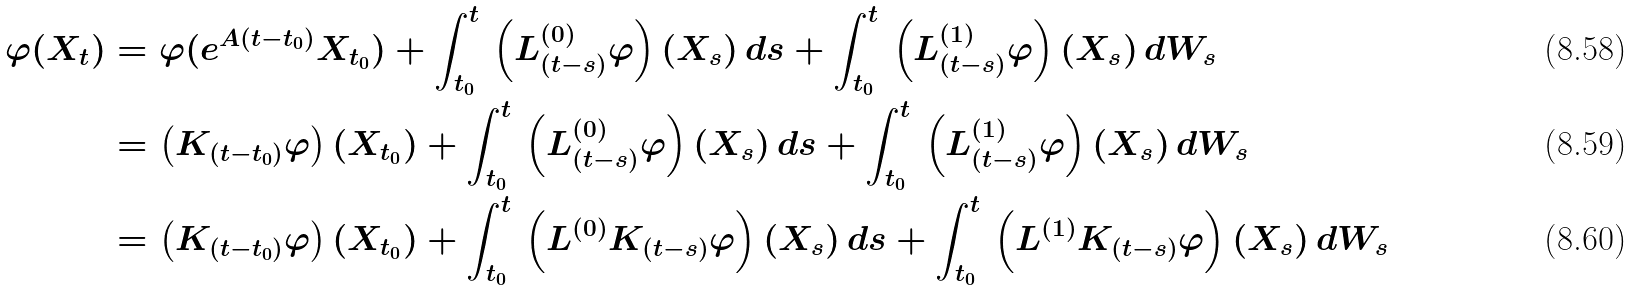<formula> <loc_0><loc_0><loc_500><loc_500>\varphi ( X _ { t } ) & = \varphi ( e ^ { A ( t - t _ { 0 } ) } X _ { t _ { 0 } } ) + \int _ { t _ { 0 } } ^ { t } \, \left ( L _ { ( t - s ) } ^ { ( 0 ) } \varphi \right ) ( X _ { s } ) \, d s + \int _ { t _ { 0 } } ^ { t } \, \left ( L _ { ( t - s ) } ^ { ( 1 ) } \varphi \right ) ( X _ { s } ) \, d W _ { s } \\ & = \left ( K _ { ( t - t _ { 0 } ) } \varphi \right ) ( X _ { t _ { 0 } } ) + \int _ { t _ { 0 } } ^ { t } \, \left ( L _ { ( t - s ) } ^ { ( 0 ) } \varphi \right ) ( X _ { s } ) \, d s + \int _ { t _ { 0 } } ^ { t } \, \left ( L _ { ( t - s ) } ^ { ( 1 ) } \varphi \right ) ( X _ { s } ) \, d W _ { s } \\ & = \left ( K _ { ( t - t _ { 0 } ) } \varphi \right ) ( X _ { t _ { 0 } } ) + \int _ { t _ { 0 } } ^ { t } \, \left ( L ^ { ( 0 ) } K _ { ( t - s ) } \varphi \right ) ( X _ { s } ) \, d s + \int _ { t _ { 0 } } ^ { t } \, \left ( L ^ { ( 1 ) } K _ { ( t - s ) } \varphi \right ) ( X _ { s } ) \, d W _ { s }</formula> 